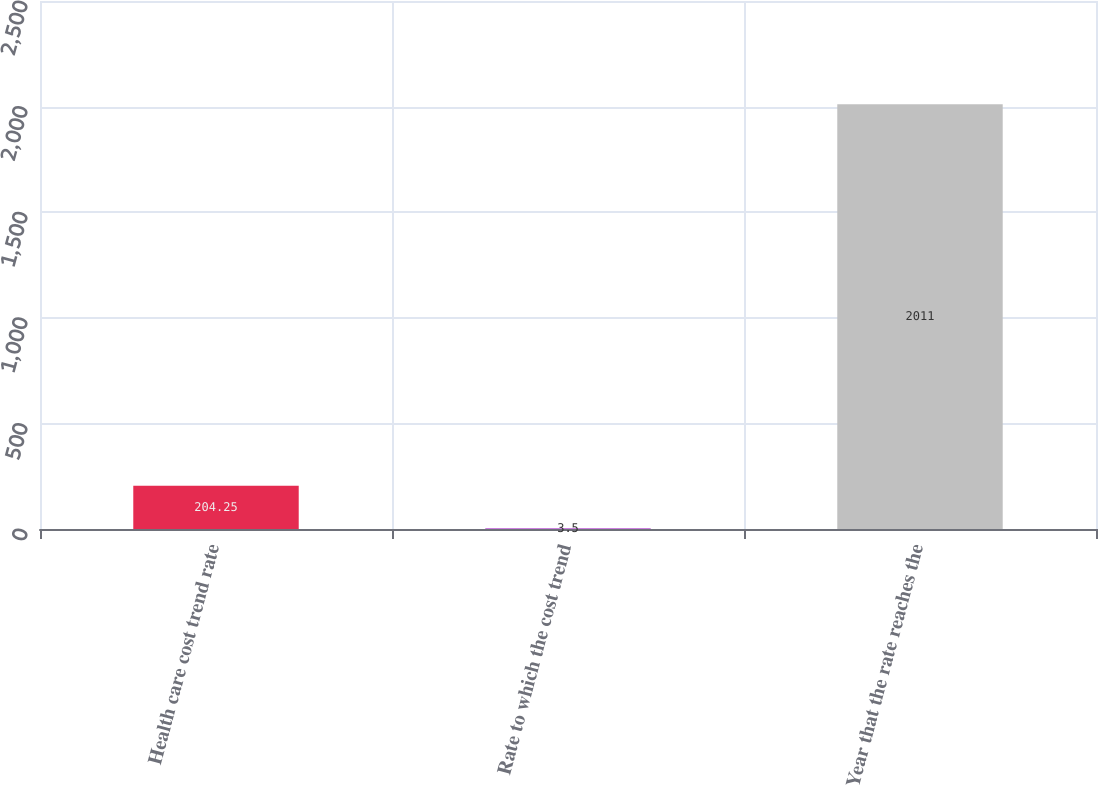<chart> <loc_0><loc_0><loc_500><loc_500><bar_chart><fcel>Health care cost trend rate<fcel>Rate to which the cost trend<fcel>Year that the rate reaches the<nl><fcel>204.25<fcel>3.5<fcel>2011<nl></chart> 